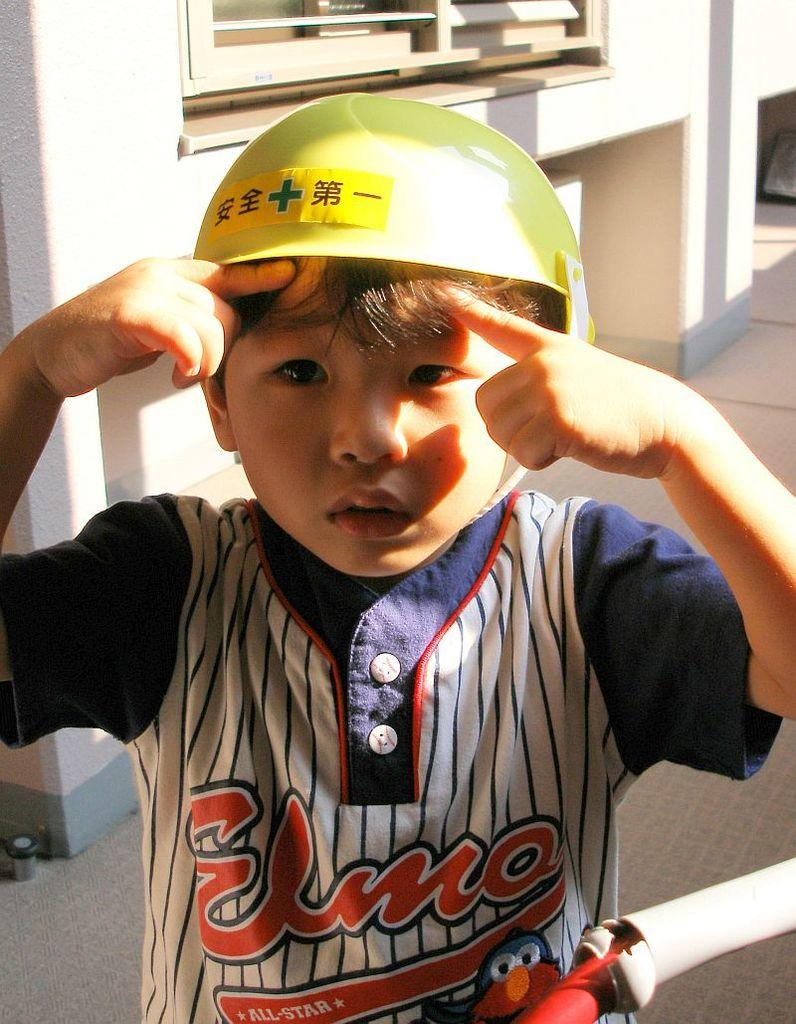Who is present in the image? There is a boy in the image. What is the boy wearing on his head? The boy is wearing a helmet. What can be seen in the background of the image? There is a wall visible in the image. How many letters can be seen on the nut in the image? There is no nut or letters present in the image. 